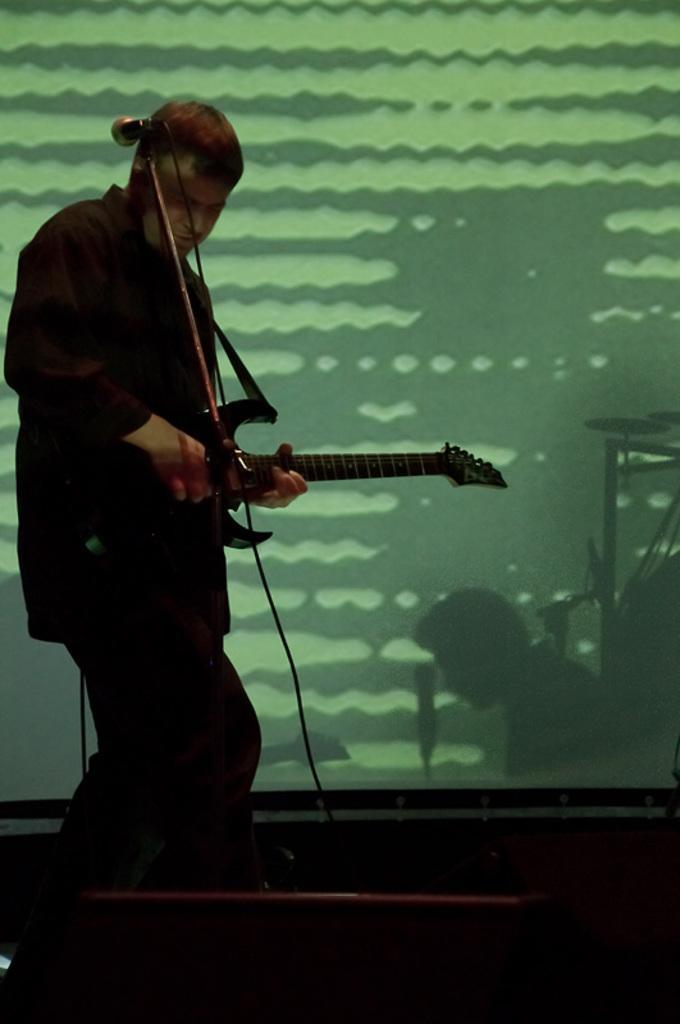Could you give a brief overview of what you see in this image? This image might be clicked in a musical concert. There is a person standing on the left side. He is playing guitar. There is a mic in front of him and behind him there is a screen. 